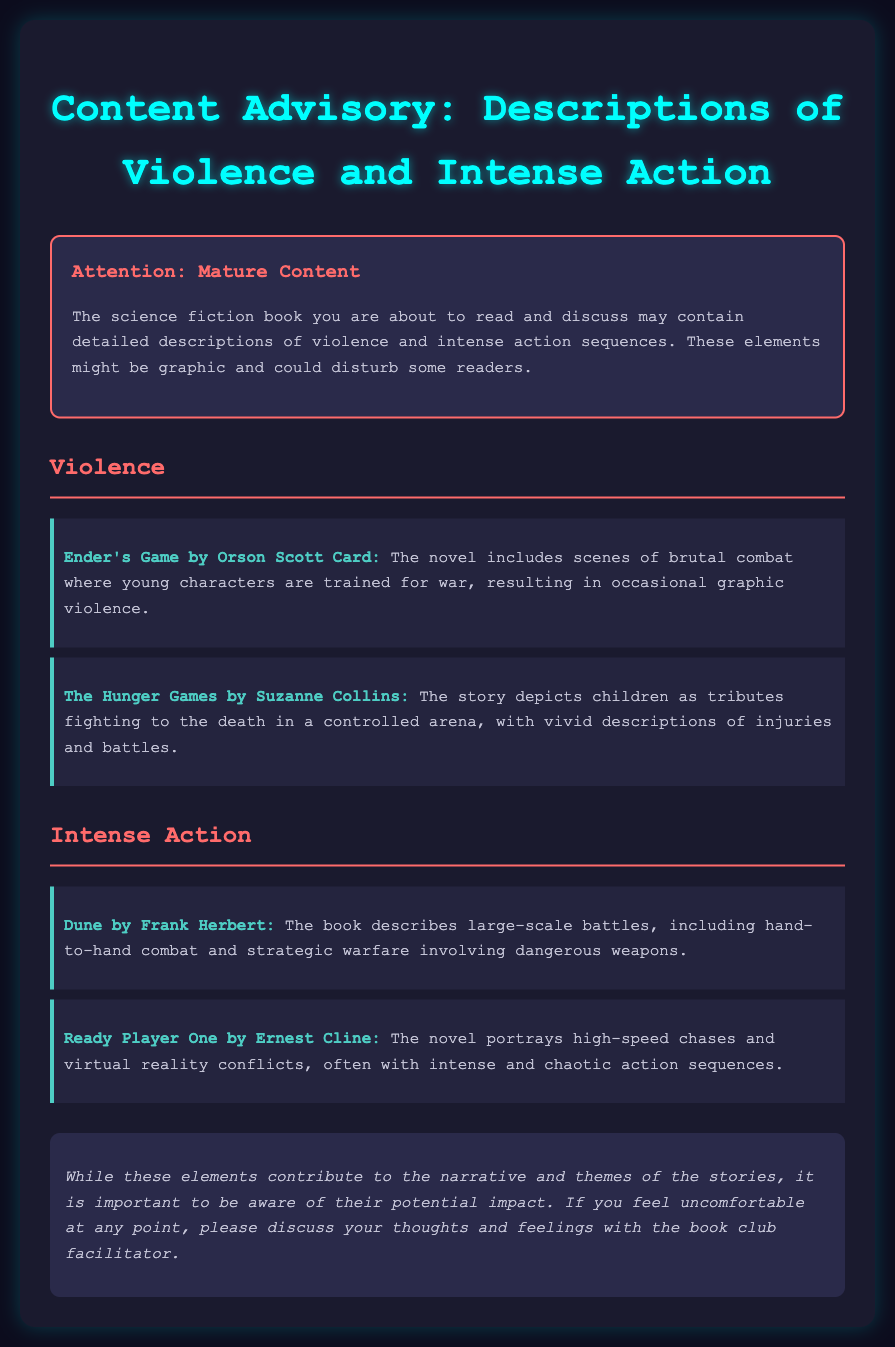What is the title of the document? The title of the document is mentioned at the top of the page.
Answer: Content Advisory: Descriptions of Violence and Intense Action What author wrote "Ender's Game"? The document lists the author of "Ender's Game" in the example provided.
Answer: Orson Scott Card Which book features children as tributes fighting to the death? This specific plot element is described in the section discussing violence.
Answer: The Hunger Games How many book examples are given under the Intense Action section? The document includes specific examples under the Intense Action heading, which can be counted.
Answer: Two What color is the warning header? The document specifies the color of the warning header in its styling details.
Answer: Red What should you do if you feel uncomfortable? The note section provides guidance on what to do in case of discomfort.
Answer: Discuss with the book club facilitator What kind of content does the warning label highlight? The document's purpose is to inform readers about the nature of the content present in the books discussed.
Answer: Violent and intense action How is the document visually structured? The document is organized with headings and examples, indicating a specific layout format for easy reading.
Answer: Sections and examples 